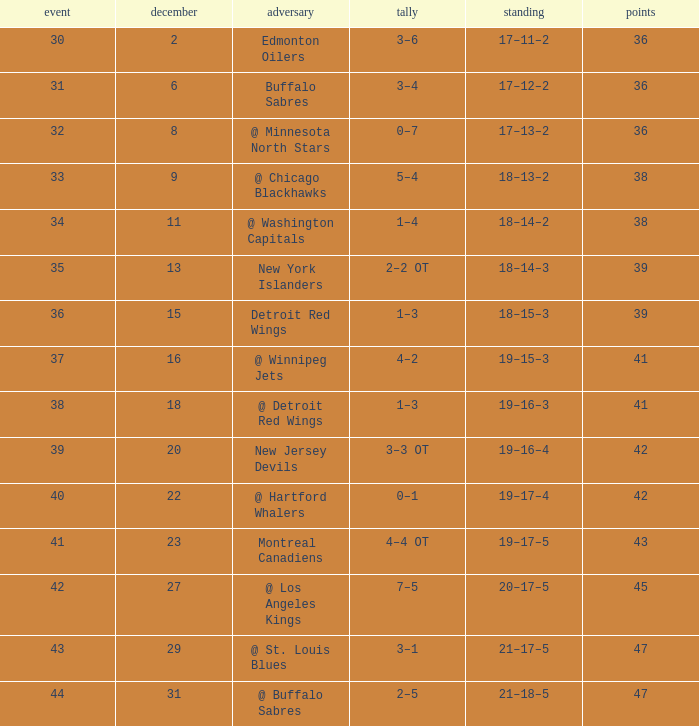After december 29 what is the score? 2–5. 